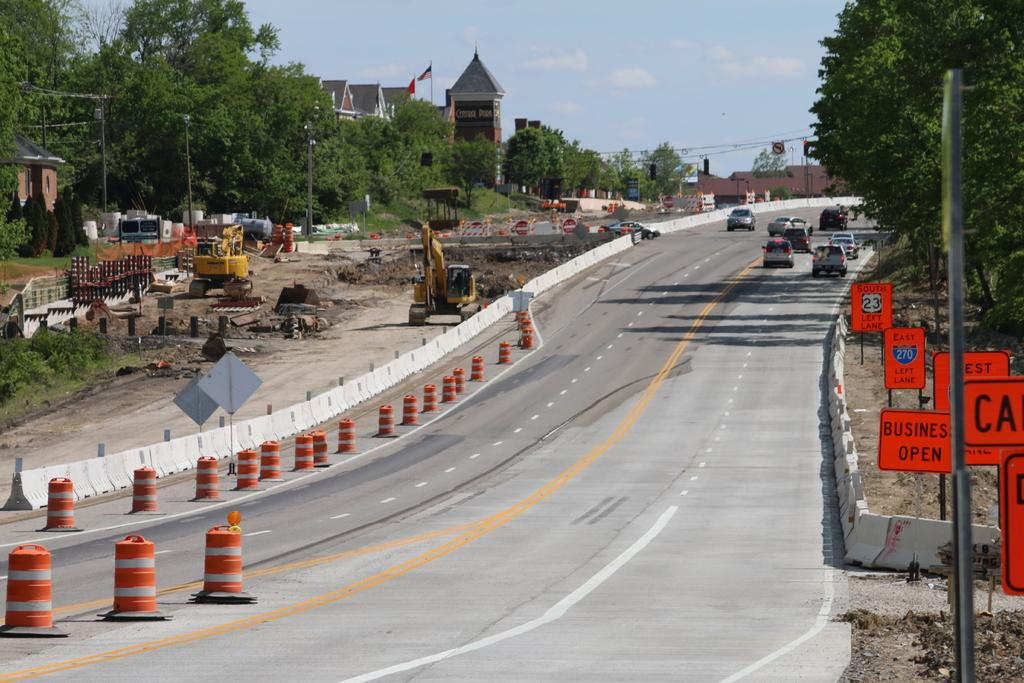What type of structures can be seen in the image? There are buildings in the image. What natural elements are present in the image? There are trees in the image. What man-made objects are related to electricity in the image? Electric poles and electric cables are visible in the image. What type of signs are present in the image? Sign boards are in the image. What safety features are visible in the image? Barrier poles are visible in the image. What construction equipment is present in the image? An excavator and a bulldozer are present in the image. What type of vehicles can be seen on the road in the image? Motor vehicles are on the road in the image. What is visible in the sky in the image? The sky is visible in the image, and clouds are present in the sky. How many friends are sitting on the back of the bulldozer in the image? There are no friends or any people sitting on the back of the bulldozer in the image. What time of day is it in the image, based on the presence of morning light? The time of day cannot be determined from the image, as there is no reference to morning light or any other time-related cues. 